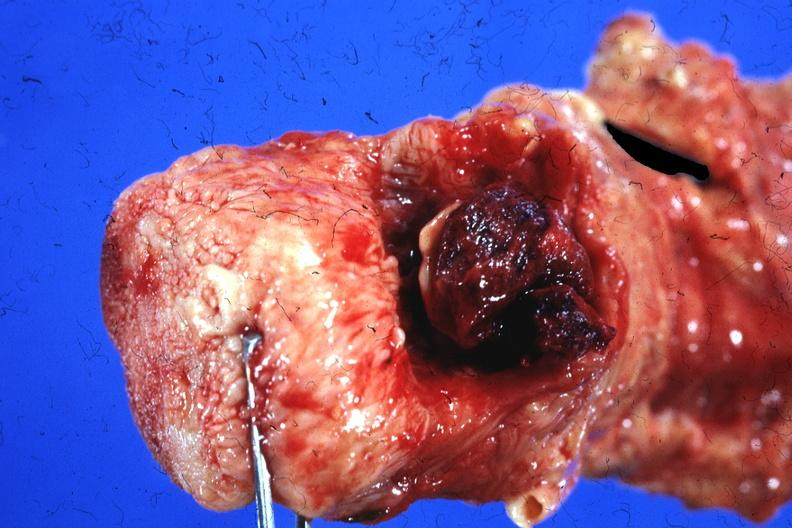where is this?
Answer the question using a single word or phrase. Oral 